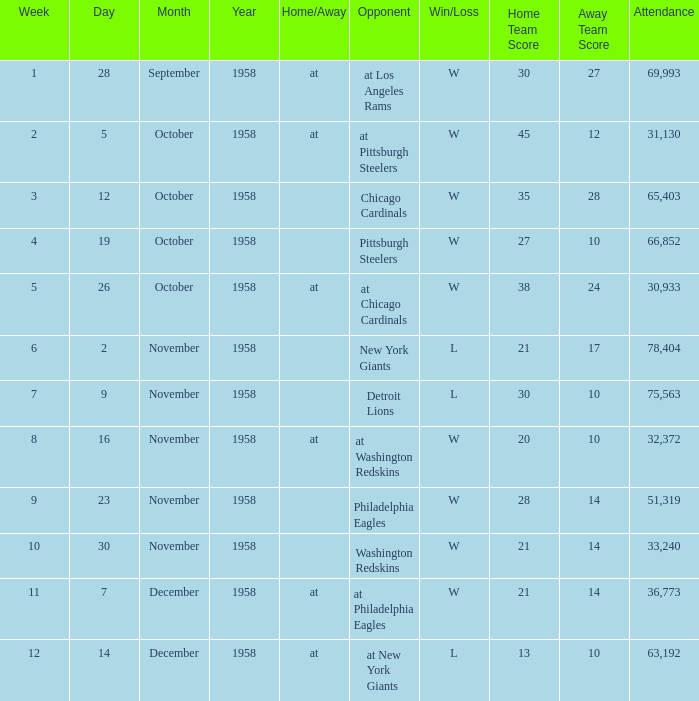On which day during week 4 did the attendance surpass 51,319? October 19, 1958. 